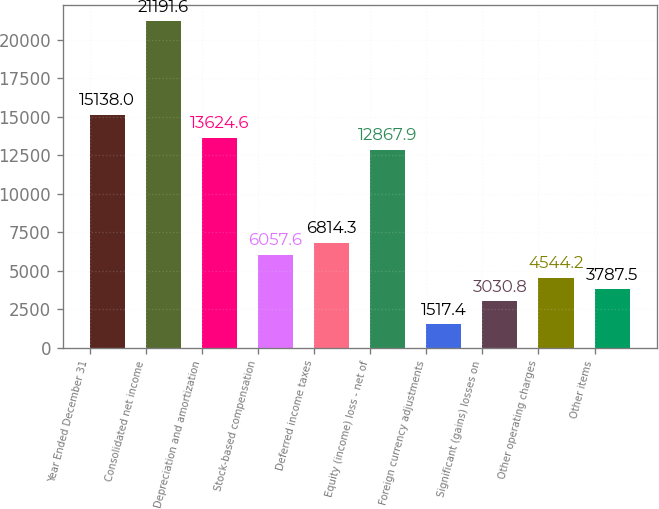Convert chart. <chart><loc_0><loc_0><loc_500><loc_500><bar_chart><fcel>Year Ended December 31<fcel>Consolidated net income<fcel>Depreciation and amortization<fcel>Stock-based compensation<fcel>Deferred income taxes<fcel>Equity (income) loss - net of<fcel>Foreign currency adjustments<fcel>Significant (gains) losses on<fcel>Other operating charges<fcel>Other items<nl><fcel>15138<fcel>21191.6<fcel>13624.6<fcel>6057.6<fcel>6814.3<fcel>12867.9<fcel>1517.4<fcel>3030.8<fcel>4544.2<fcel>3787.5<nl></chart> 